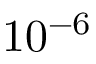<formula> <loc_0><loc_0><loc_500><loc_500>1 0 ^ { - 6 }</formula> 